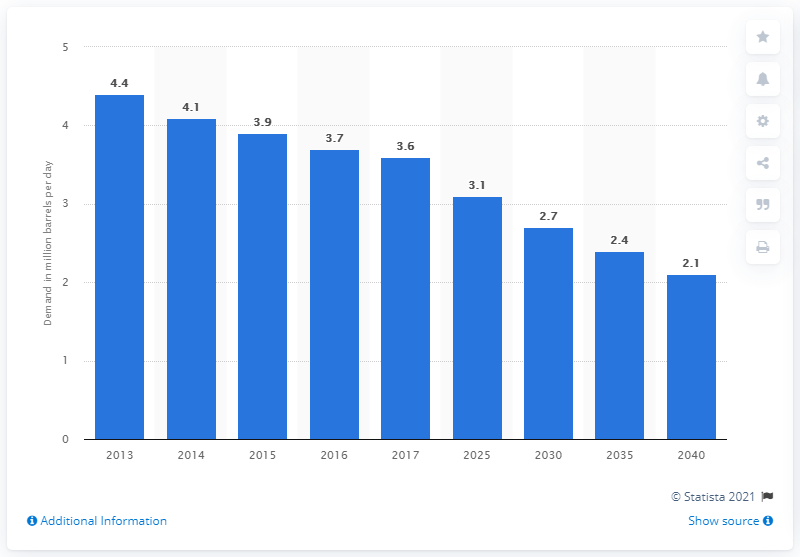Give some essential details in this illustration. The projected demand for oil in Japan in 2040 is expected to be 2.1 barrels per day. In 2013, the demand for oil was 4.4 million barrels per day. 